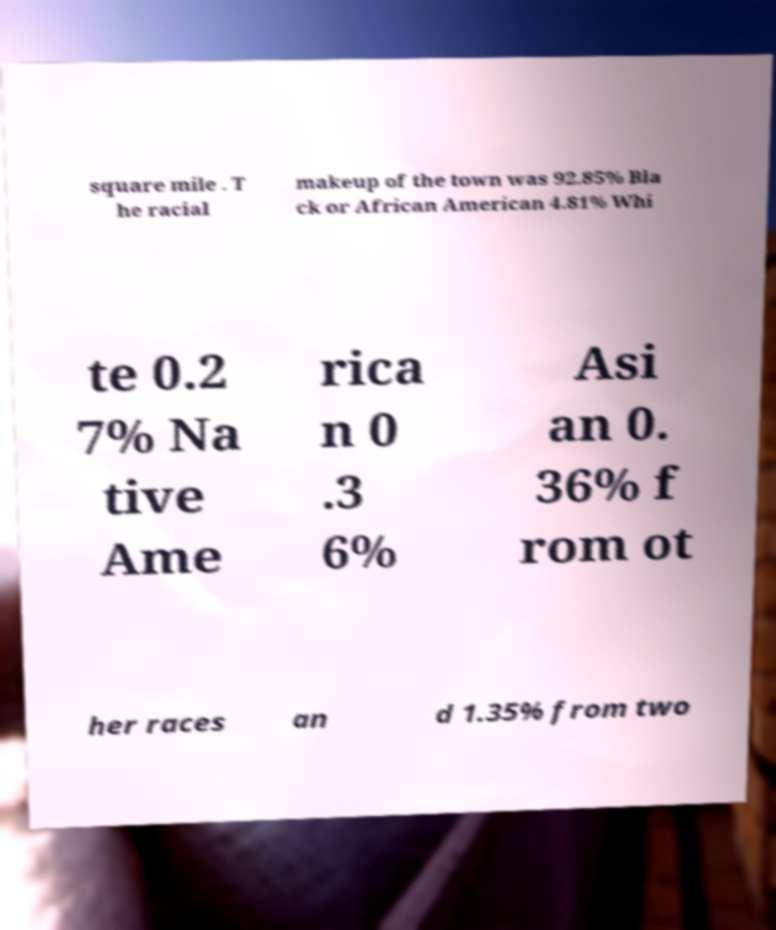Please read and relay the text visible in this image. What does it say? square mile . T he racial makeup of the town was 92.85% Bla ck or African American 4.81% Whi te 0.2 7% Na tive Ame rica n 0 .3 6% Asi an 0. 36% f rom ot her races an d 1.35% from two 